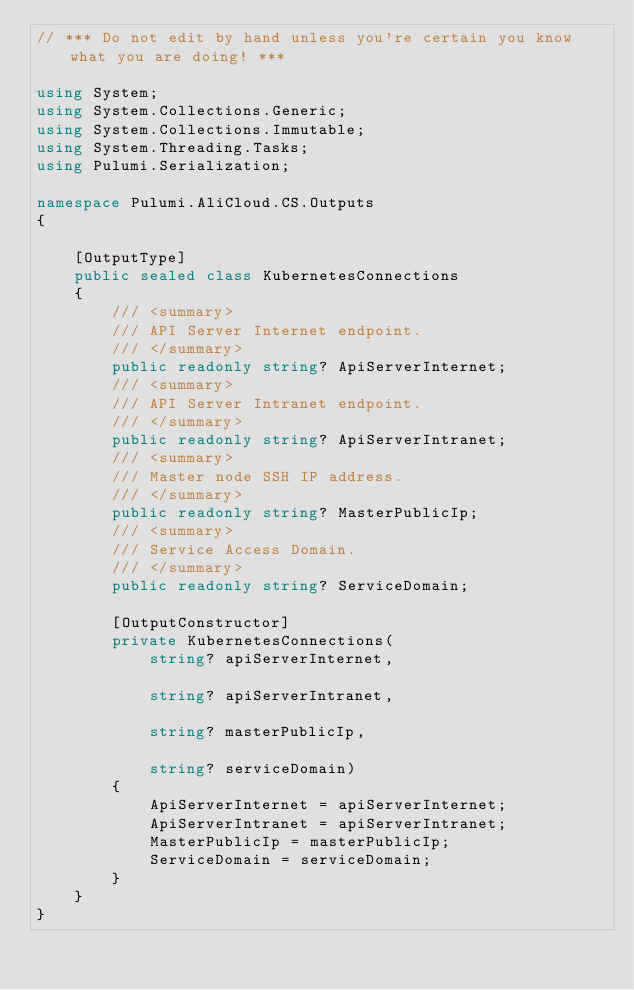Convert code to text. <code><loc_0><loc_0><loc_500><loc_500><_C#_>// *** Do not edit by hand unless you're certain you know what you are doing! ***

using System;
using System.Collections.Generic;
using System.Collections.Immutable;
using System.Threading.Tasks;
using Pulumi.Serialization;

namespace Pulumi.AliCloud.CS.Outputs
{

    [OutputType]
    public sealed class KubernetesConnections
    {
        /// <summary>
        /// API Server Internet endpoint.
        /// </summary>
        public readonly string? ApiServerInternet;
        /// <summary>
        /// API Server Intranet endpoint.
        /// </summary>
        public readonly string? ApiServerIntranet;
        /// <summary>
        /// Master node SSH IP address.
        /// </summary>
        public readonly string? MasterPublicIp;
        /// <summary>
        /// Service Access Domain.
        /// </summary>
        public readonly string? ServiceDomain;

        [OutputConstructor]
        private KubernetesConnections(
            string? apiServerInternet,

            string? apiServerIntranet,

            string? masterPublicIp,

            string? serviceDomain)
        {
            ApiServerInternet = apiServerInternet;
            ApiServerIntranet = apiServerIntranet;
            MasterPublicIp = masterPublicIp;
            ServiceDomain = serviceDomain;
        }
    }
}
</code> 